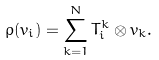Convert formula to latex. <formula><loc_0><loc_0><loc_500><loc_500>\rho ( v _ { i } ) = \sum _ { k = 1 } ^ { N } T _ { i } ^ { k } \otimes v _ { k } .</formula> 